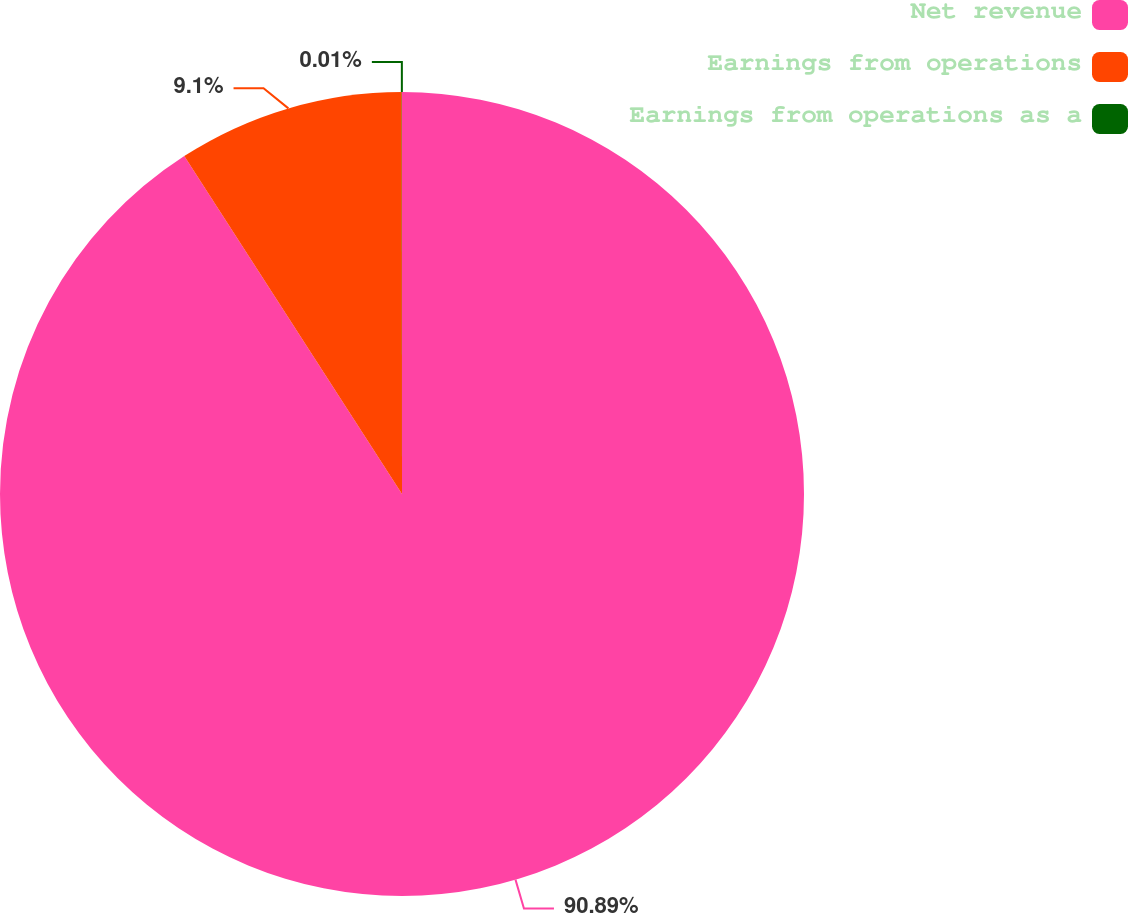Convert chart. <chart><loc_0><loc_0><loc_500><loc_500><pie_chart><fcel>Net revenue<fcel>Earnings from operations<fcel>Earnings from operations as a<nl><fcel>90.89%<fcel>9.1%<fcel>0.01%<nl></chart> 